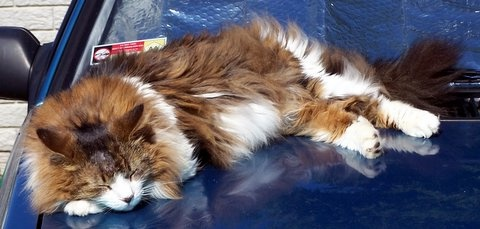Describe the objects in this image and their specific colors. I can see a cat in lightgray, gray, white, black, and maroon tones in this image. 